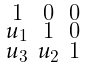Convert formula to latex. <formula><loc_0><loc_0><loc_500><loc_500>\begin{smallmatrix} 1 & 0 & 0 \\ u _ { 1 } & 1 & 0 \\ u _ { 3 } & u _ { 2 } & 1 \end{smallmatrix}</formula> 